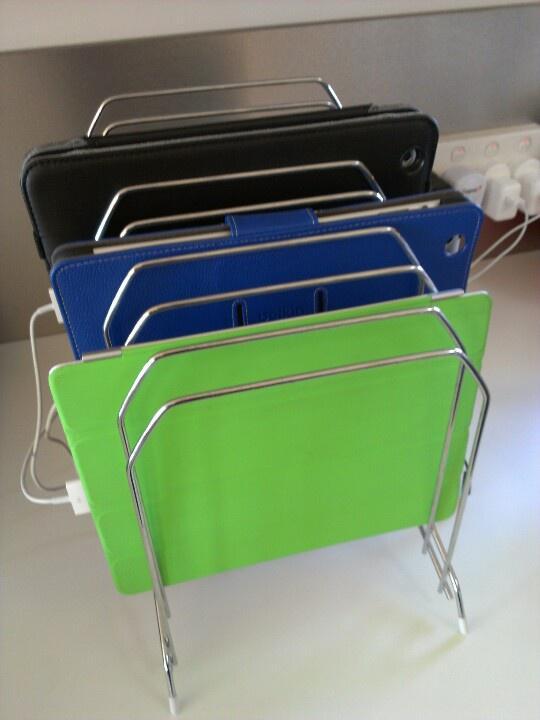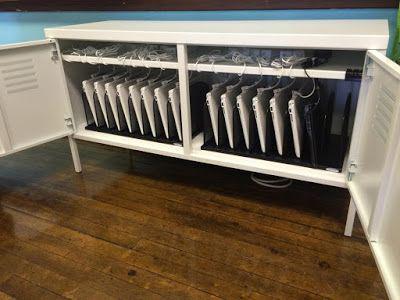The first image is the image on the left, the second image is the image on the right. Considering the images on both sides, is "One image shows laptops stacked directly on top of each other, and the other image shows a shelved unit that stores laptops horizontally in multiple rows." valid? Answer yes or no. No. The first image is the image on the left, the second image is the image on the right. Evaluate the accuracy of this statement regarding the images: "All of the computers are sitting flat.". Is it true? Answer yes or no. No. 